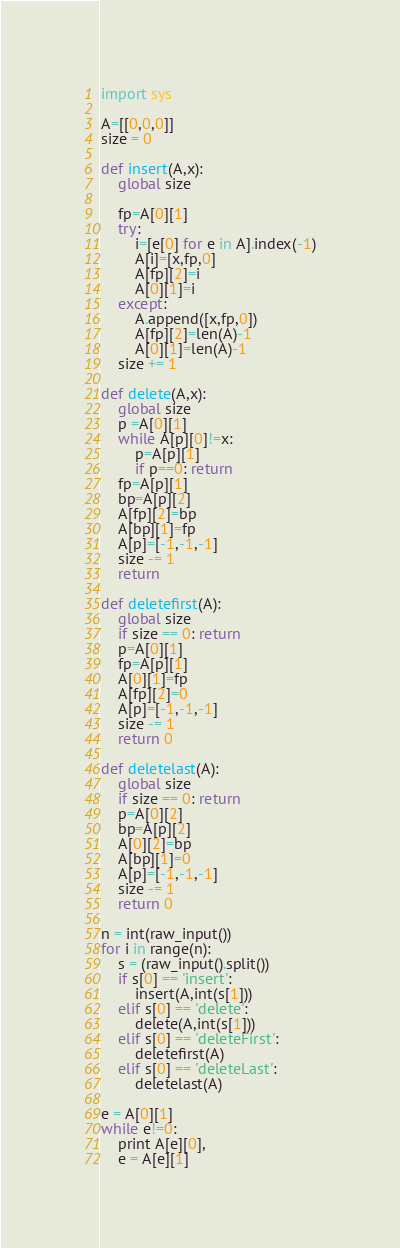<code> <loc_0><loc_0><loc_500><loc_500><_Python_>import sys

A=[[0,0,0]]
size = 0

def insert(A,x):
    global size

    fp=A[0][1]
    try:
        i=[e[0] for e in A].index(-1)
        A[i]=[x,fp,0]
        A[fp][2]=i
        A[0][1]=i
    except:
        A.append([x,fp,0])
        A[fp][2]=len(A)-1
        A[0][1]=len(A)-1     
    size += 1    

def delete(A,x):
    global size
    p =A[0][1]
    while A[p][0]!=x:
        p=A[p][1]
        if p==0: return
    fp=A[p][1]
    bp=A[p][2]
    A[fp][2]=bp
    A[bp][1]=fp
    A[p]=[-1,-1,-1]
    size -= 1
    return

def deletefirst(A):
    global size
    if size == 0: return
    p=A[0][1]
    fp=A[p][1]
    A[0][1]=fp
    A[fp][2]=0
    A[p]=[-1,-1,-1]
    size -= 1
    return 0

def deletelast(A):
    global size
    if size == 0: return
    p=A[0][2]
    bp=A[p][2]
    A[0][2]=bp
    A[bp][1]=0
    A[p]=[-1,-1,-1]
    size -= 1
    return 0

n = int(raw_input())
for i in range(n):
    s = (raw_input().split())
    if s[0] == 'insert':
        insert(A,int(s[1]))
    elif s[0] == 'delete':
        delete(A,int(s[1]))
    elif s[0] == 'deleteFirst':
        deletefirst(A)
    elif s[0] == 'deleteLast':
        deletelast(A)

e = A[0][1]
while e!=0:
    print A[e][0],
    e = A[e][1]</code> 